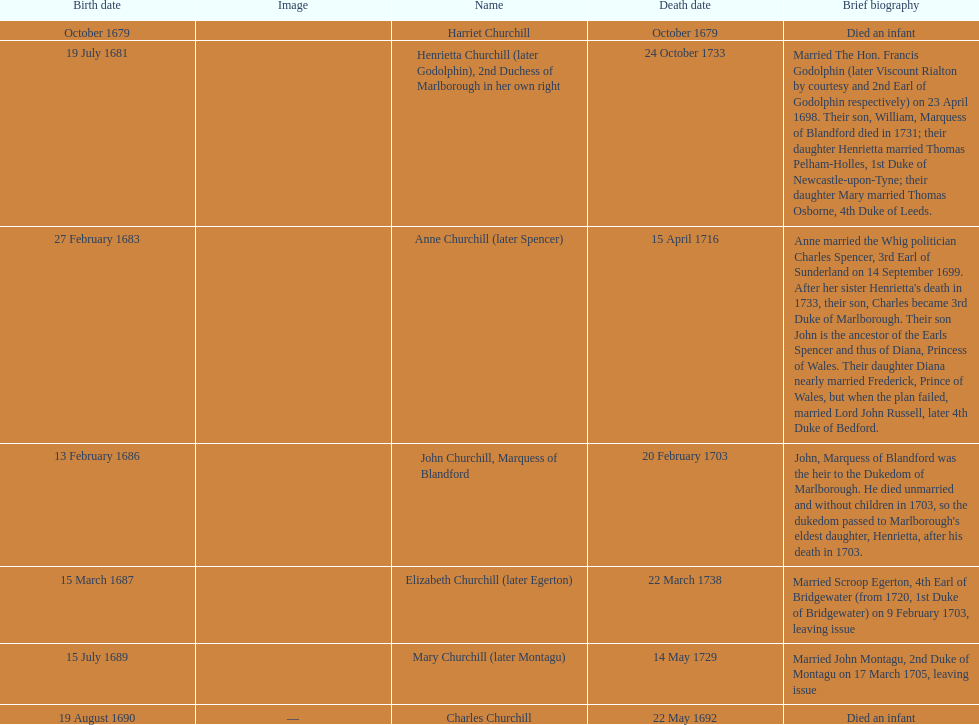How many children were born in february? 2. 